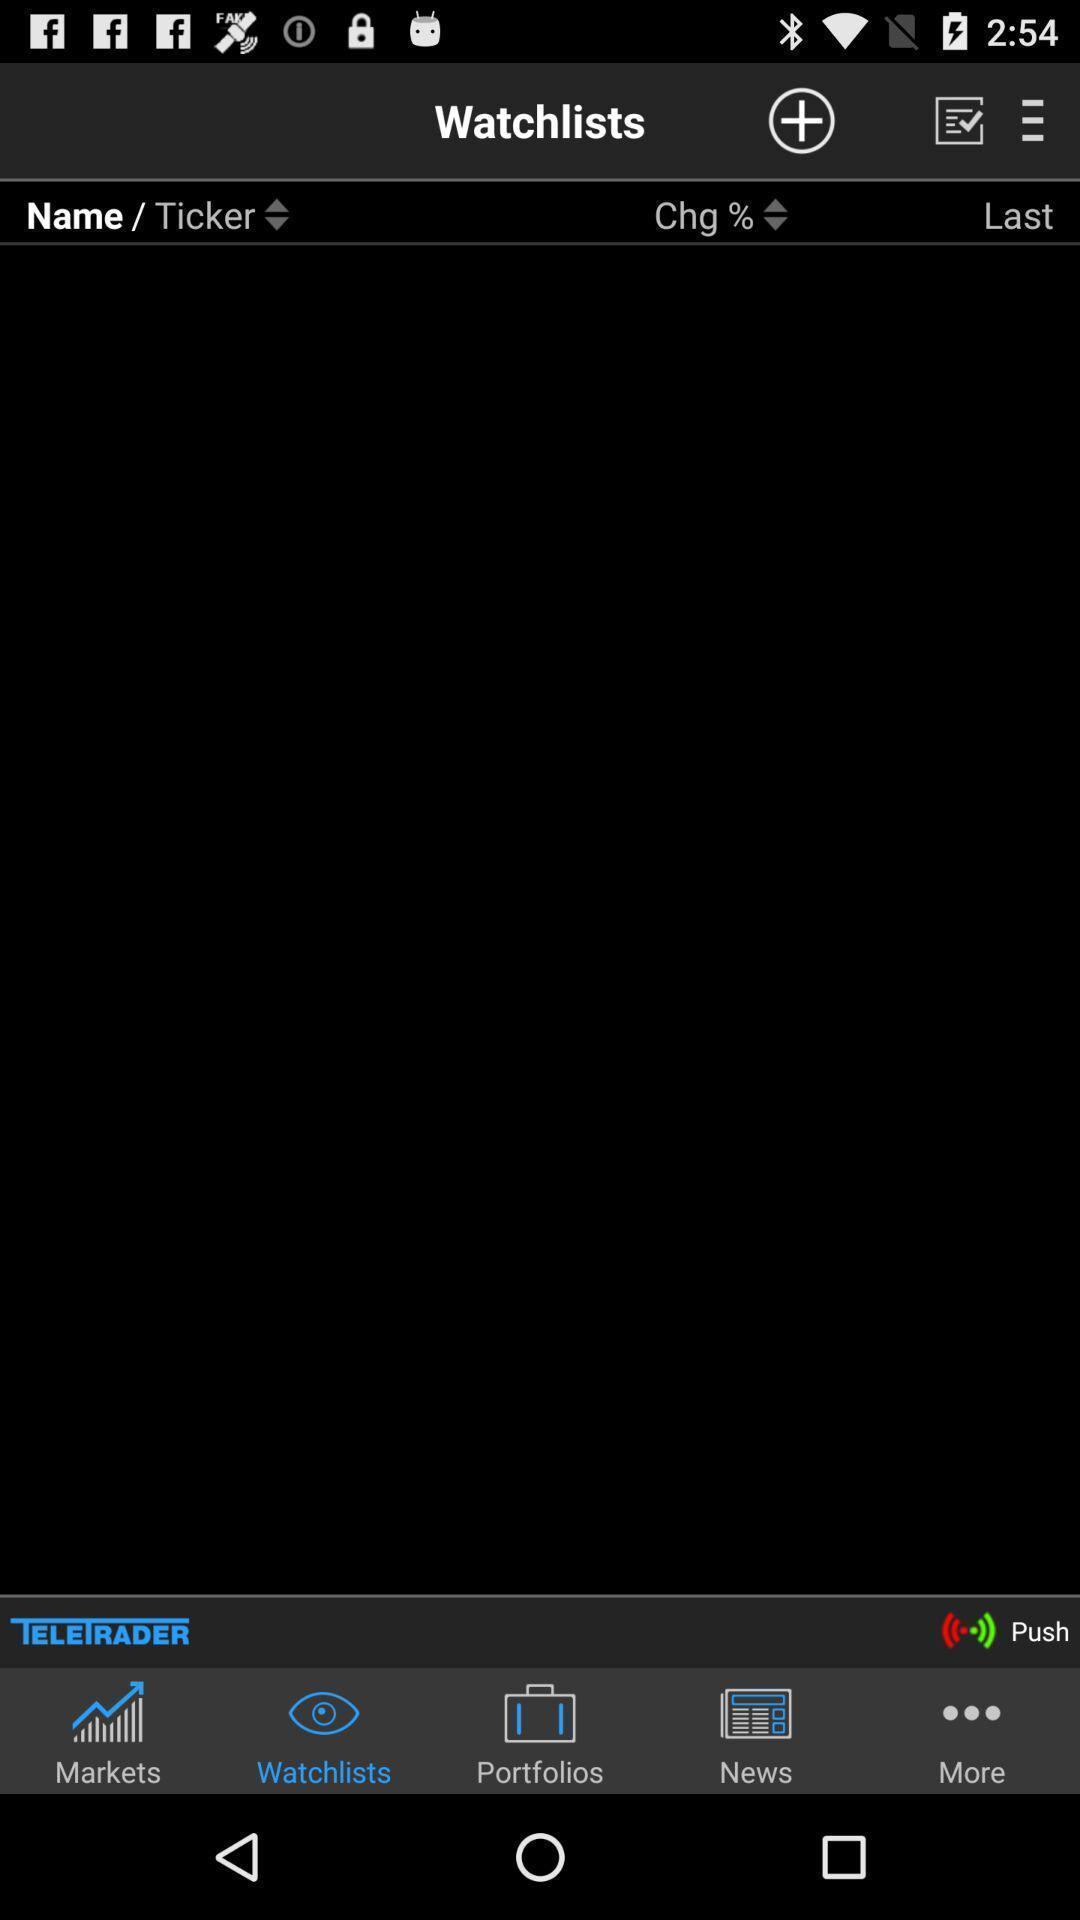Provide a textual representation of this image. Screen displaying multiple options in a finance application. 